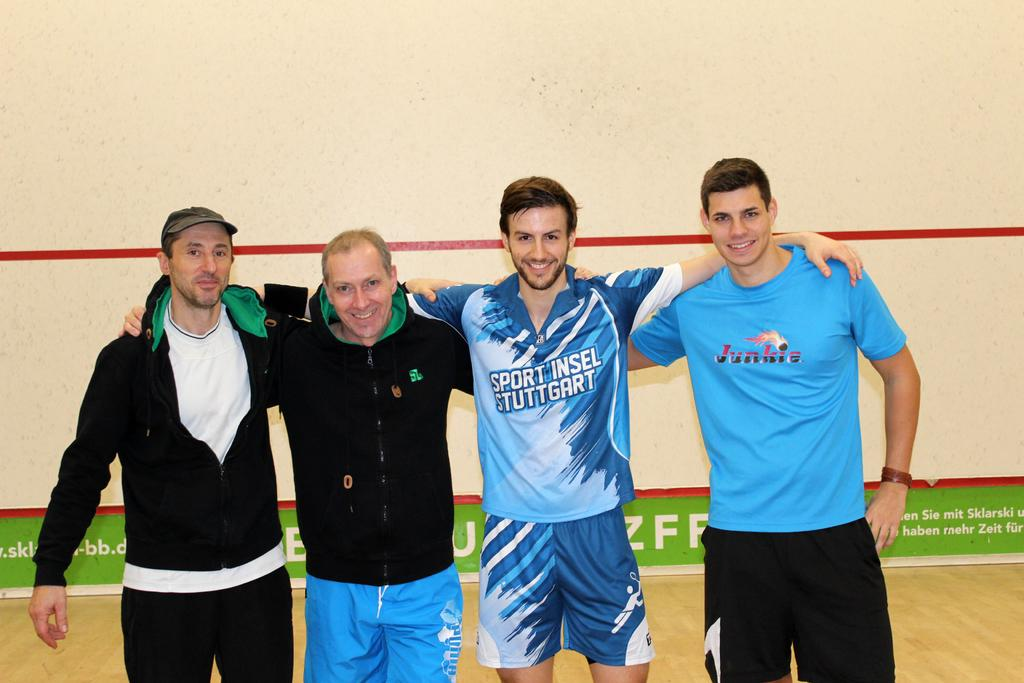<image>
Write a terse but informative summary of the picture. A man wearing a Sport Insel Stuttgart shirt standing shoulder to shoulder with three other men. 